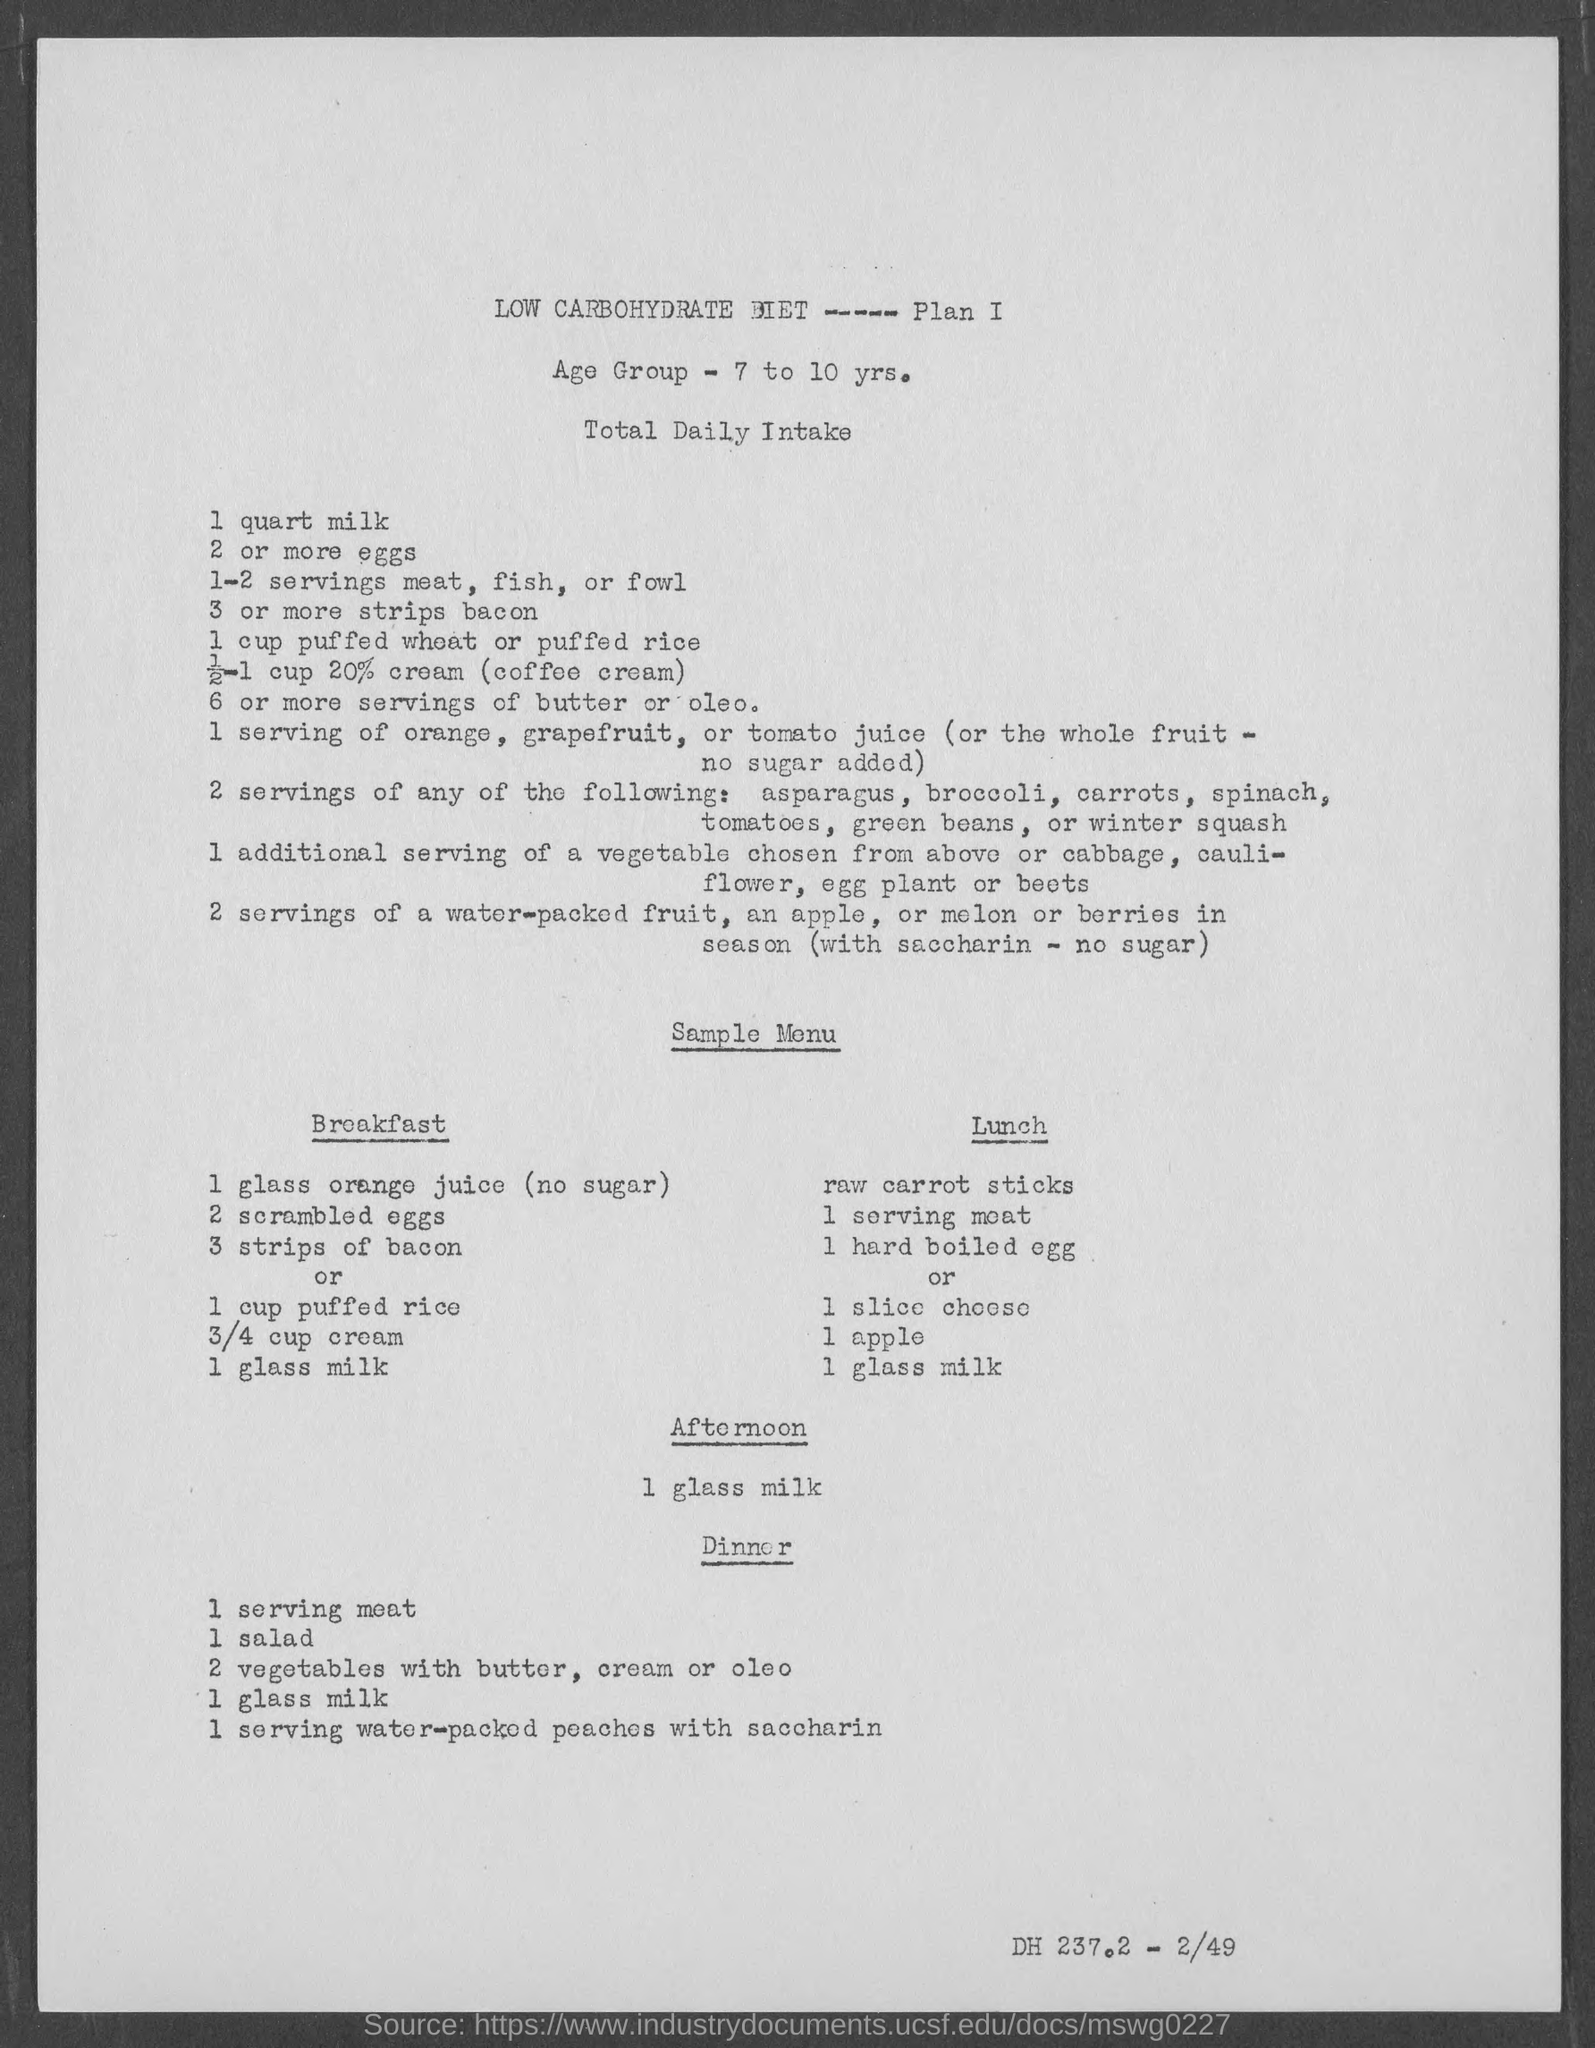What is the Age Group?
Your answer should be very brief. 7 to 10 yrs. What is the Sample Menu for Afternoon?
Your response must be concise. 1 glass milk. What is the Total Daily Intake of milk?
Keep it short and to the point. 1 quart. 